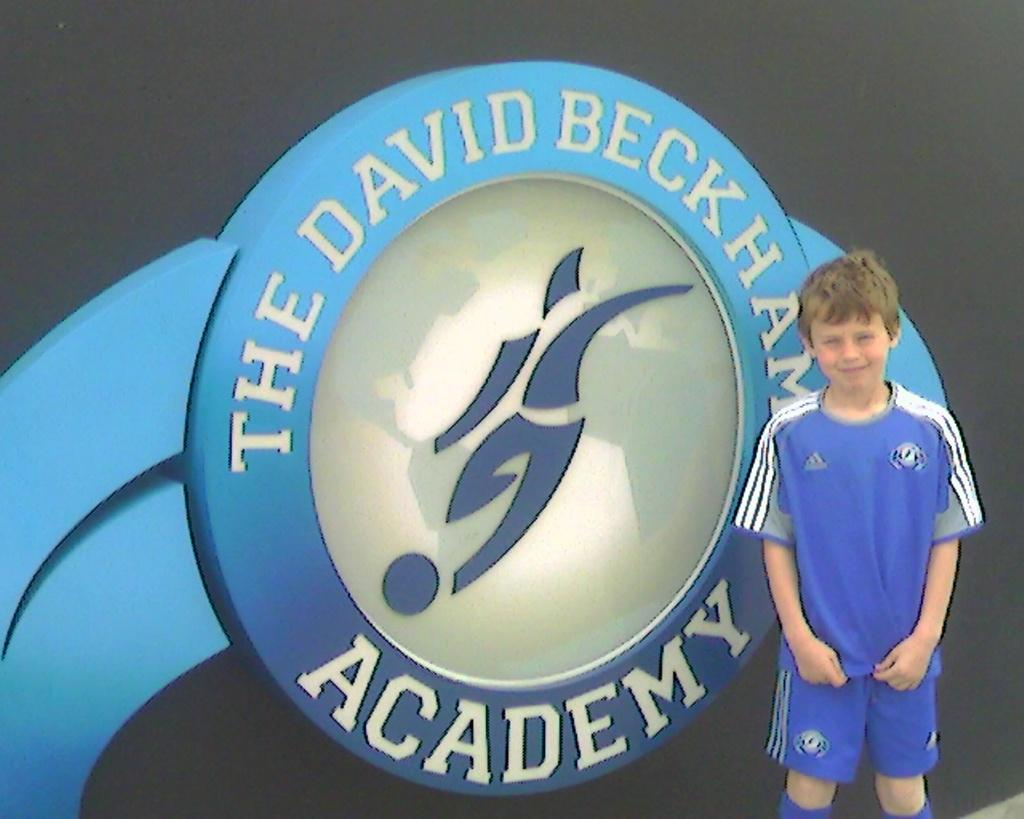<image>
Summarize the visual content of the image. the word academy is on the sign next to a boy 